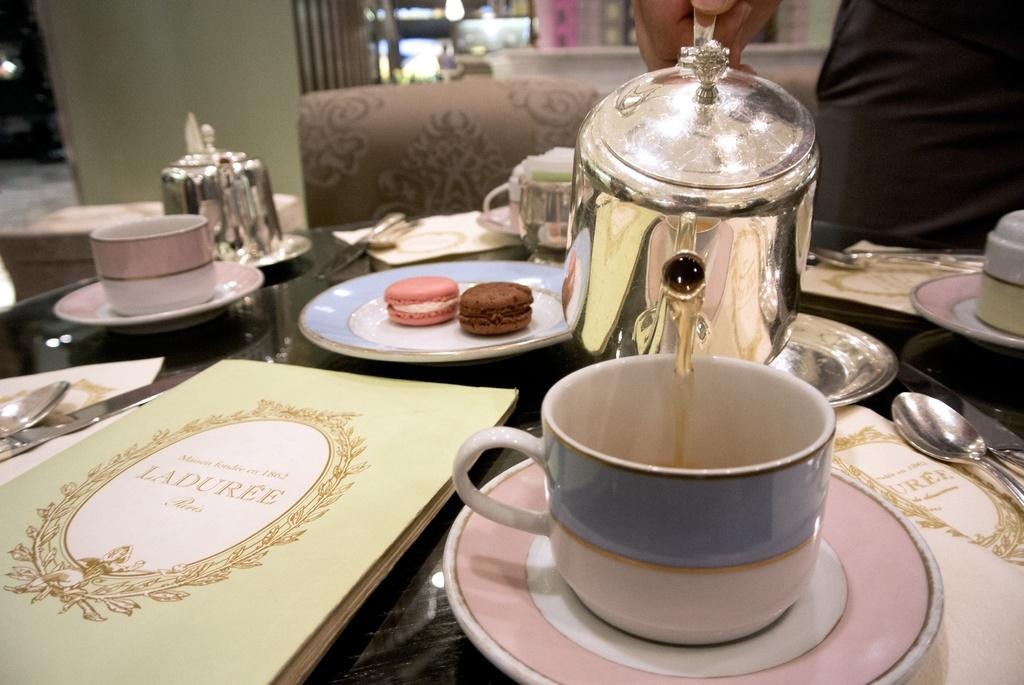What piece of furniture is visible in the image? There is a table in the image. What is placed on the table? There is a tea cup, a plate, and food items on the table. What else can be seen on the table? There are objects on the table. Is there any seating visible in the image? Yes, there is a chair in the image. What hobbies are being celebrated at the birthday event in the image? There is no mention of a birthday event or any hobbies in the image. The image only shows a table with various items on it and a chair. 